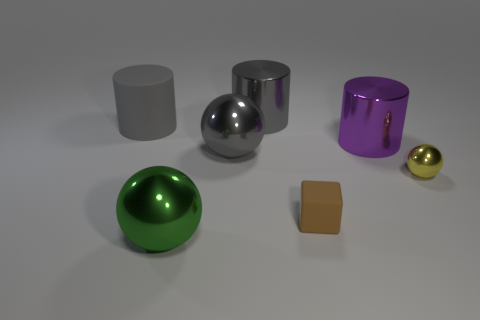Subtract all gray metal cylinders. How many cylinders are left? 2 Add 2 big purple balls. How many objects exist? 9 Subtract all green spheres. How many spheres are left? 2 Subtract all cylinders. How many objects are left? 4 Add 4 yellow objects. How many yellow objects exist? 5 Subtract 1 brown blocks. How many objects are left? 6 Subtract 2 spheres. How many spheres are left? 1 Subtract all purple cylinders. Subtract all purple cubes. How many cylinders are left? 2 Subtract all purple cylinders. How many cyan cubes are left? 0 Subtract all tiny shiny balls. Subtract all yellow spheres. How many objects are left? 5 